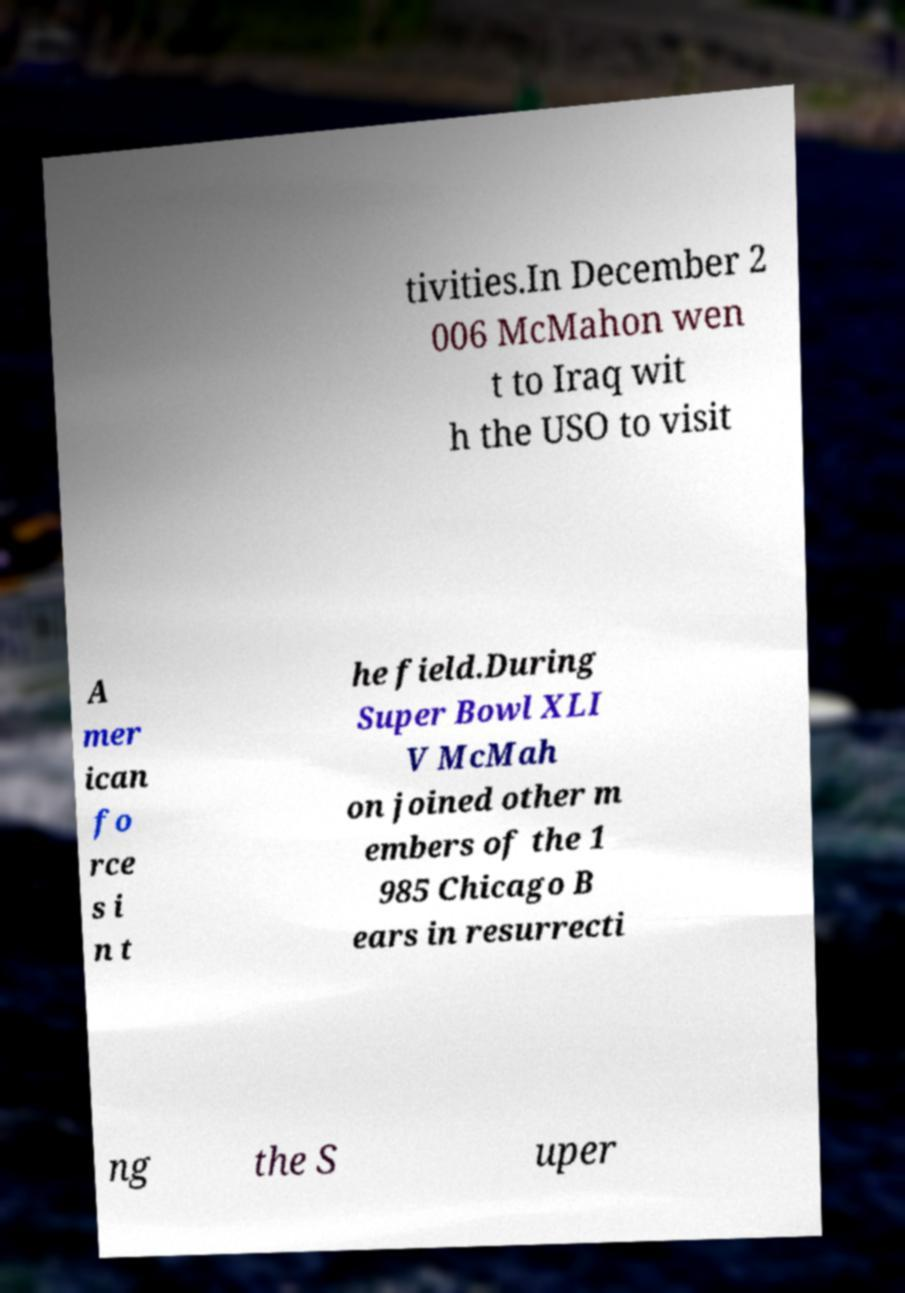I need the written content from this picture converted into text. Can you do that? tivities.In December 2 006 McMahon wen t to Iraq wit h the USO to visit A mer ican fo rce s i n t he field.During Super Bowl XLI V McMah on joined other m embers of the 1 985 Chicago B ears in resurrecti ng the S uper 